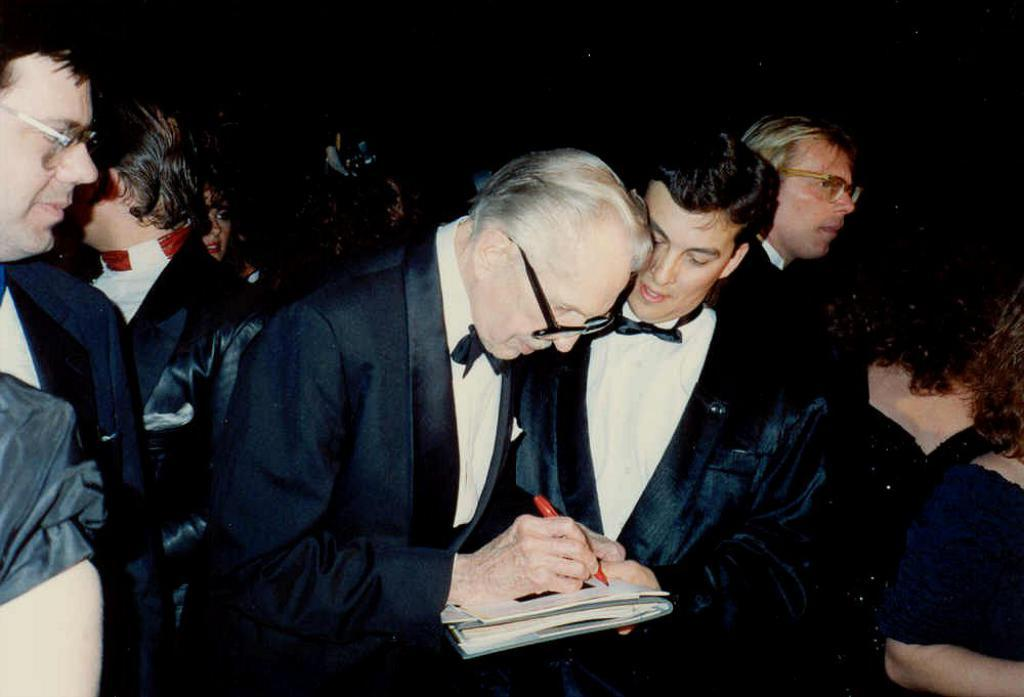How many people are in the image? There are people in the image, but the exact number is not specified. What are the people wearing in the image? The people are wearing the same costume in the image. Can you describe the person holding an object in the middle of the image? Yes, there is a person holding an object in the middle of the image. What type of plantation can be seen in the background of the image? There is no plantation visible in the image. How many rays are emanating from the person holding the object in the middle of the image? There are no rays present in the image. 